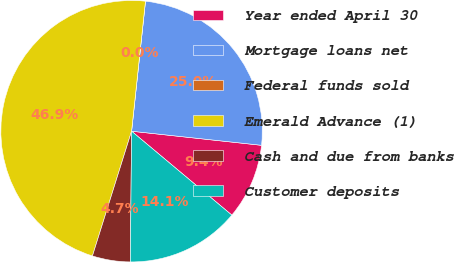Convert chart. <chart><loc_0><loc_0><loc_500><loc_500><pie_chart><fcel>Year ended April 30<fcel>Mortgage loans net<fcel>Federal funds sold<fcel>Emerald Advance (1)<fcel>Cash and due from banks<fcel>Customer deposits<nl><fcel>9.37%<fcel>25.03%<fcel>0.0%<fcel>46.86%<fcel>4.69%<fcel>14.06%<nl></chart> 